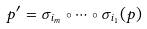Convert formula to latex. <formula><loc_0><loc_0><loc_500><loc_500>p ^ { \prime } = \sigma _ { i _ { m } } \circ \dots \circ \sigma _ { i _ { 1 } } ( p )</formula> 